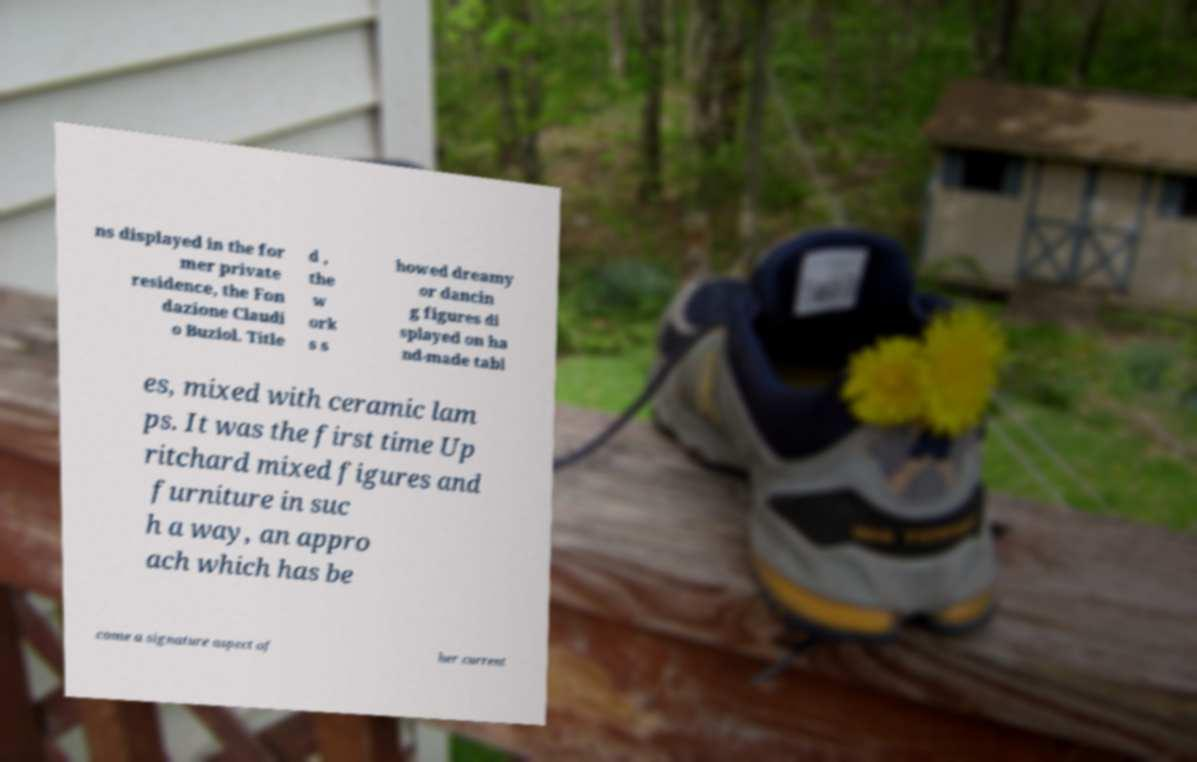Can you read and provide the text displayed in the image?This photo seems to have some interesting text. Can you extract and type it out for me? ns displayed in the for mer private residence, the Fon dazione Claudi o Buziol. Title d , the w ork s s howed dreamy or dancin g figures di splayed on ha nd-made tabl es, mixed with ceramic lam ps. It was the first time Up ritchard mixed figures and furniture in suc h a way, an appro ach which has be come a signature aspect of her current 